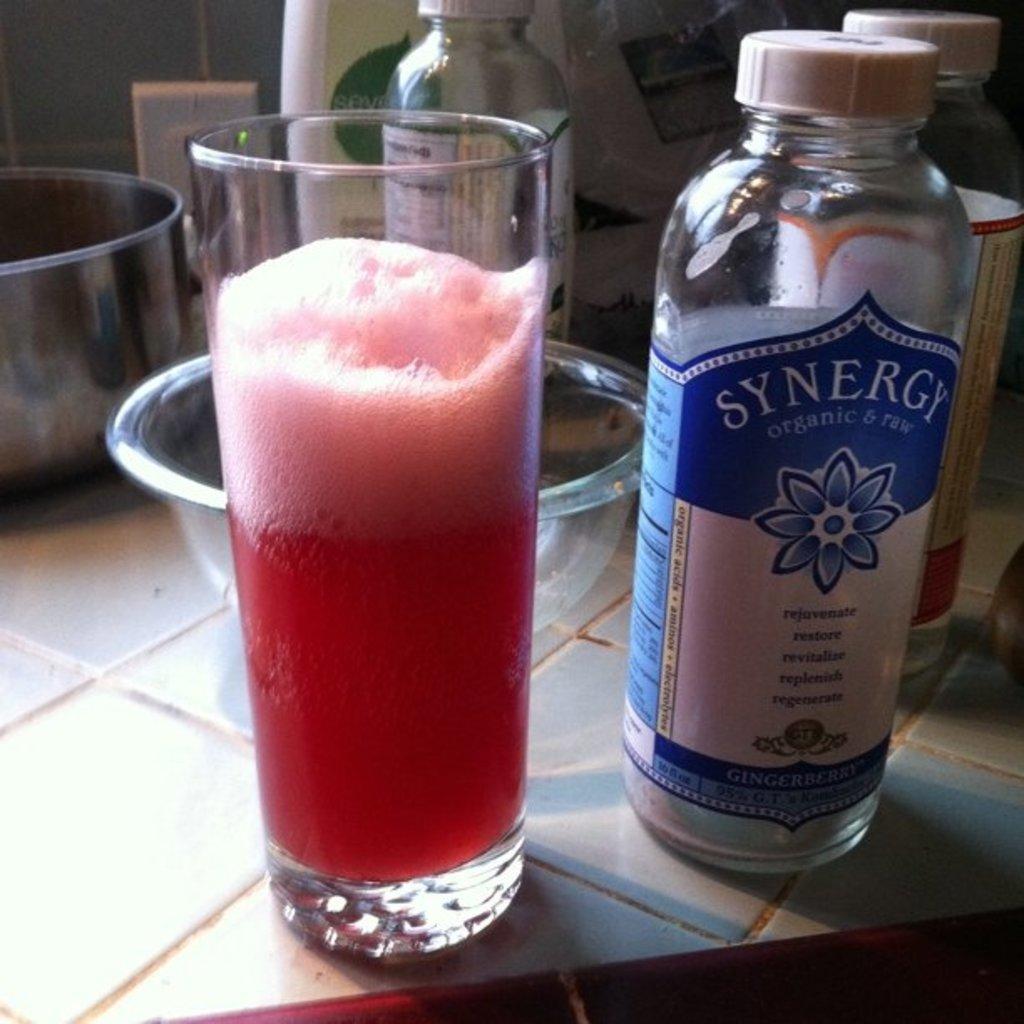What is the brand of the tea on the right?
Ensure brevity in your answer.  Synergy. 